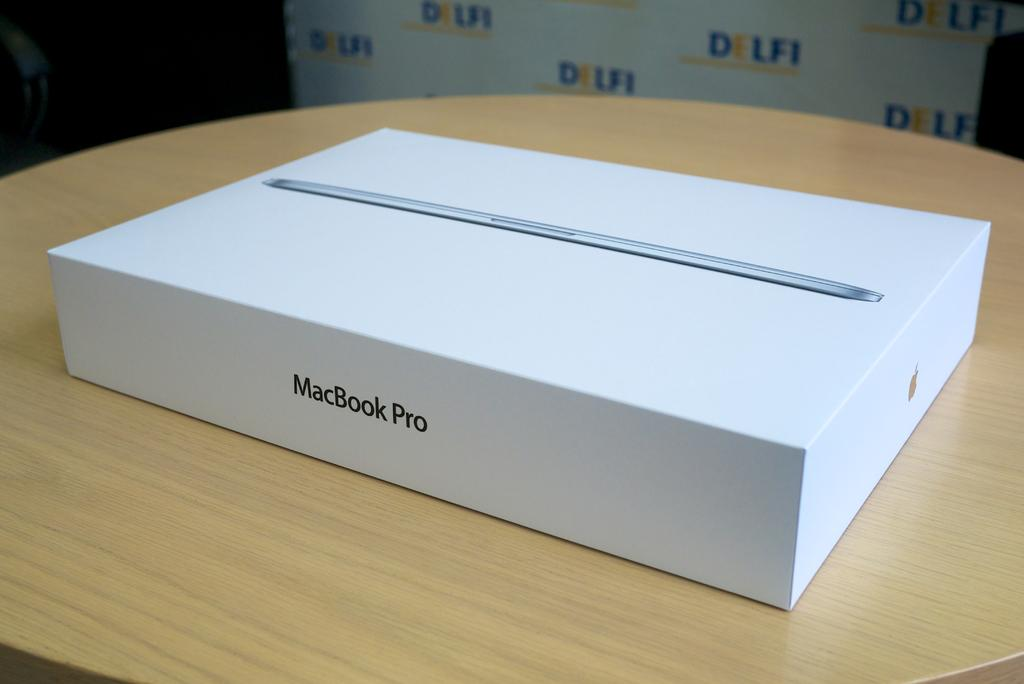<image>
Give a short and clear explanation of the subsequent image. An unopened MacBook Pro sits on the table in front of a DELFI advertisement. 